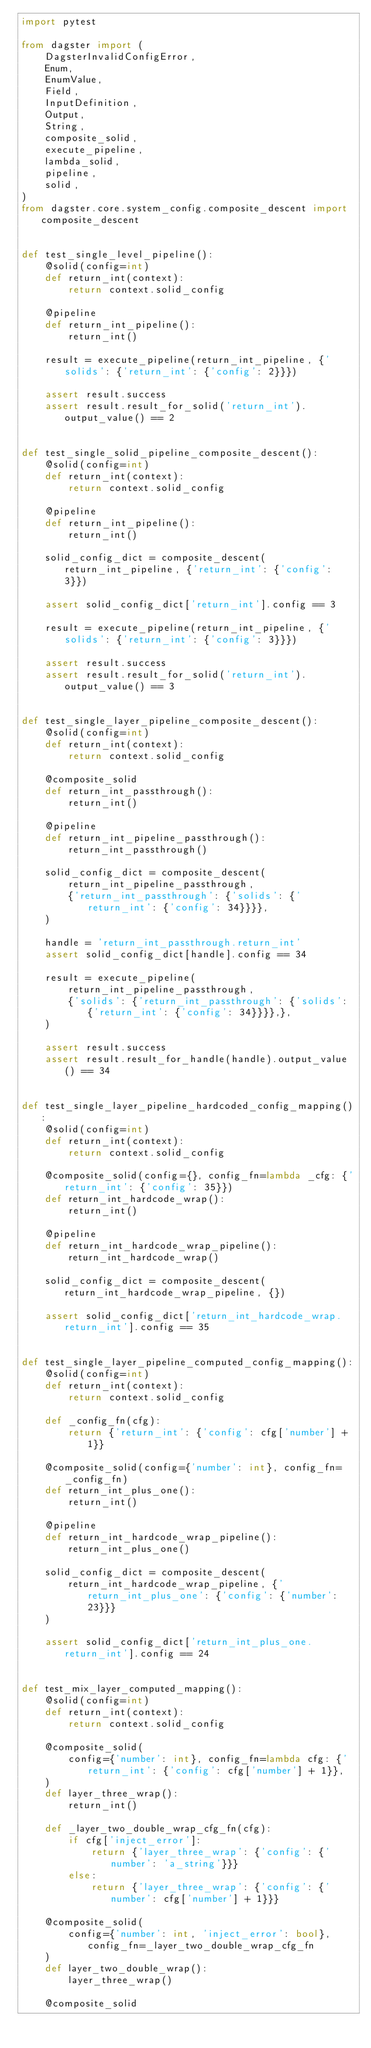Convert code to text. <code><loc_0><loc_0><loc_500><loc_500><_Python_>import pytest

from dagster import (
    DagsterInvalidConfigError,
    Enum,
    EnumValue,
    Field,
    InputDefinition,
    Output,
    String,
    composite_solid,
    execute_pipeline,
    lambda_solid,
    pipeline,
    solid,
)
from dagster.core.system_config.composite_descent import composite_descent


def test_single_level_pipeline():
    @solid(config=int)
    def return_int(context):
        return context.solid_config

    @pipeline
    def return_int_pipeline():
        return_int()

    result = execute_pipeline(return_int_pipeline, {'solids': {'return_int': {'config': 2}}})

    assert result.success
    assert result.result_for_solid('return_int').output_value() == 2


def test_single_solid_pipeline_composite_descent():
    @solid(config=int)
    def return_int(context):
        return context.solid_config

    @pipeline
    def return_int_pipeline():
        return_int()

    solid_config_dict = composite_descent(return_int_pipeline, {'return_int': {'config': 3}})

    assert solid_config_dict['return_int'].config == 3

    result = execute_pipeline(return_int_pipeline, {'solids': {'return_int': {'config': 3}}})

    assert result.success
    assert result.result_for_solid('return_int').output_value() == 3


def test_single_layer_pipeline_composite_descent():
    @solid(config=int)
    def return_int(context):
        return context.solid_config

    @composite_solid
    def return_int_passthrough():
        return_int()

    @pipeline
    def return_int_pipeline_passthrough():
        return_int_passthrough()

    solid_config_dict = composite_descent(
        return_int_pipeline_passthrough,
        {'return_int_passthrough': {'solids': {'return_int': {'config': 34}}}},
    )

    handle = 'return_int_passthrough.return_int'
    assert solid_config_dict[handle].config == 34

    result = execute_pipeline(
        return_int_pipeline_passthrough,
        {'solids': {'return_int_passthrough': {'solids': {'return_int': {'config': 34}}}},},
    )

    assert result.success
    assert result.result_for_handle(handle).output_value() == 34


def test_single_layer_pipeline_hardcoded_config_mapping():
    @solid(config=int)
    def return_int(context):
        return context.solid_config

    @composite_solid(config={}, config_fn=lambda _cfg: {'return_int': {'config': 35}})
    def return_int_hardcode_wrap():
        return_int()

    @pipeline
    def return_int_hardcode_wrap_pipeline():
        return_int_hardcode_wrap()

    solid_config_dict = composite_descent(return_int_hardcode_wrap_pipeline, {})

    assert solid_config_dict['return_int_hardcode_wrap.return_int'].config == 35


def test_single_layer_pipeline_computed_config_mapping():
    @solid(config=int)
    def return_int(context):
        return context.solid_config

    def _config_fn(cfg):
        return {'return_int': {'config': cfg['number'] + 1}}

    @composite_solid(config={'number': int}, config_fn=_config_fn)
    def return_int_plus_one():
        return_int()

    @pipeline
    def return_int_hardcode_wrap_pipeline():
        return_int_plus_one()

    solid_config_dict = composite_descent(
        return_int_hardcode_wrap_pipeline, {'return_int_plus_one': {'config': {'number': 23}}}
    )

    assert solid_config_dict['return_int_plus_one.return_int'].config == 24


def test_mix_layer_computed_mapping():
    @solid(config=int)
    def return_int(context):
        return context.solid_config

    @composite_solid(
        config={'number': int}, config_fn=lambda cfg: {'return_int': {'config': cfg['number'] + 1}},
    )
    def layer_three_wrap():
        return_int()

    def _layer_two_double_wrap_cfg_fn(cfg):
        if cfg['inject_error']:
            return {'layer_three_wrap': {'config': {'number': 'a_string'}}}
        else:
            return {'layer_three_wrap': {'config': {'number': cfg['number'] + 1}}}

    @composite_solid(
        config={'number': int, 'inject_error': bool}, config_fn=_layer_two_double_wrap_cfg_fn
    )
    def layer_two_double_wrap():
        layer_three_wrap()

    @composite_solid</code> 